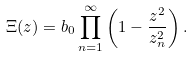<formula> <loc_0><loc_0><loc_500><loc_500>\Xi ( z ) & = b _ { 0 } \prod _ { n = 1 } ^ { \infty } \left ( 1 - \frac { z ^ { 2 } } { z _ { n } ^ { 2 } } \right ) .</formula> 